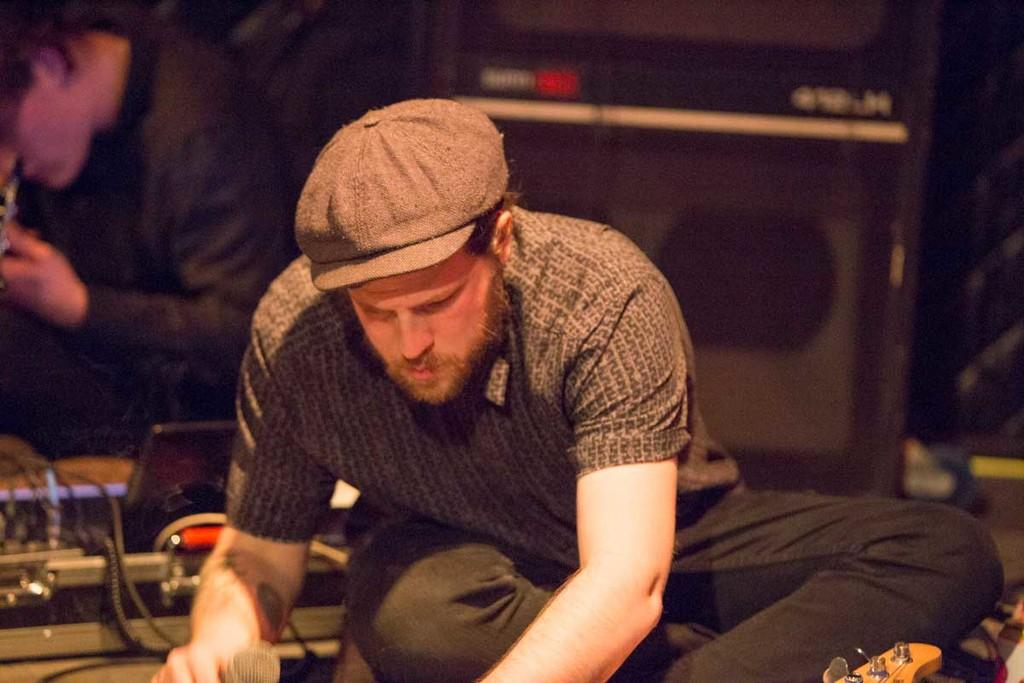What is the person in the image holding? The person is holding a mic in the image. Where is the person holding the mic sitting? The person is sitting on the floor. Can you describe the other person visible in the image? There is another person visible in the image, but their specific actions or features are not mentioned in the provided facts. What else can be seen in the image besides the people? There are musical instruments in the image. What type of hole can be seen in the image? There is no hole present in the image. What sense is being utilized by the person holding the mic? The provided facts do not mention any specific sense being utilized by the person holding the mic. 